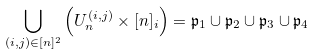Convert formula to latex. <formula><loc_0><loc_0><loc_500><loc_500>\bigcup _ { ( i , j ) \in [ n ] ^ { 2 } } \left ( U _ { n } ^ { ( i , j ) } \times [ n ] _ { i } \right ) = \mathfrak { p } _ { 1 } \cup \mathfrak { p } _ { 2 } \cup \mathfrak { p } _ { 3 } \cup \mathfrak { p } _ { 4 }</formula> 